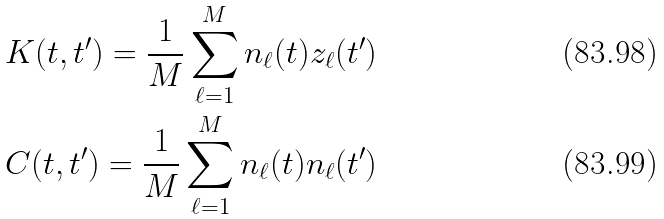<formula> <loc_0><loc_0><loc_500><loc_500>K ( t , t ^ { \prime } ) = \frac { 1 } { M } \sum _ { \ell = 1 } ^ { M } n _ { \ell } ( t ) z _ { \ell } ( t ^ { \prime } ) \\ C ( t , t ^ { \prime } ) = \frac { 1 } { M } \sum _ { \ell = 1 } ^ { M } n _ { \ell } ( t ) n _ { \ell } ( t ^ { \prime } )</formula> 